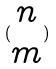<formula> <loc_0><loc_0><loc_500><loc_500>( \begin{matrix} n \\ m \end{matrix} )</formula> 